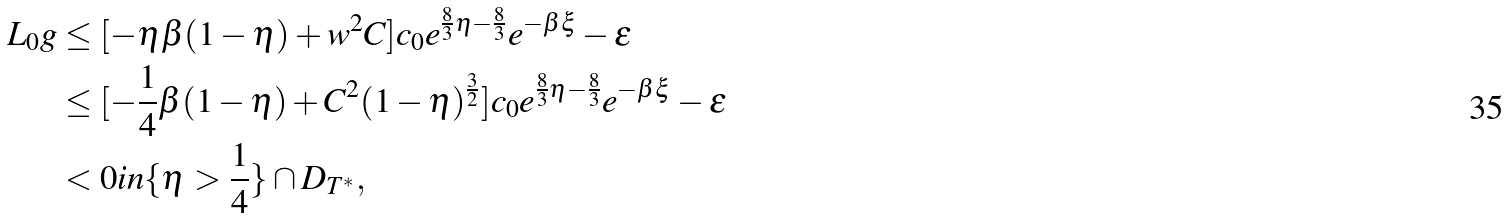Convert formula to latex. <formula><loc_0><loc_0><loc_500><loc_500>L _ { 0 } g & \leq [ - \eta \beta ( 1 - \eta ) + w ^ { 2 } C ] c _ { 0 } e ^ { \frac { 8 } { 3 } \eta - \frac { 8 } { 3 } } e ^ { - \beta \xi } - \varepsilon \\ & \leq [ - \frac { 1 } { 4 } \beta ( 1 - \eta ) + C ^ { 2 } ( 1 - \eta ) ^ { \frac { 3 } { 2 } } ] c _ { 0 } e ^ { \frac { 8 } { 3 } \eta - \frac { 8 } { 3 } } e ^ { - \beta \xi } - \varepsilon \\ & < 0 i n \{ \eta > \frac { 1 } { 4 } \} \cap D _ { T ^ { * } } ,</formula> 